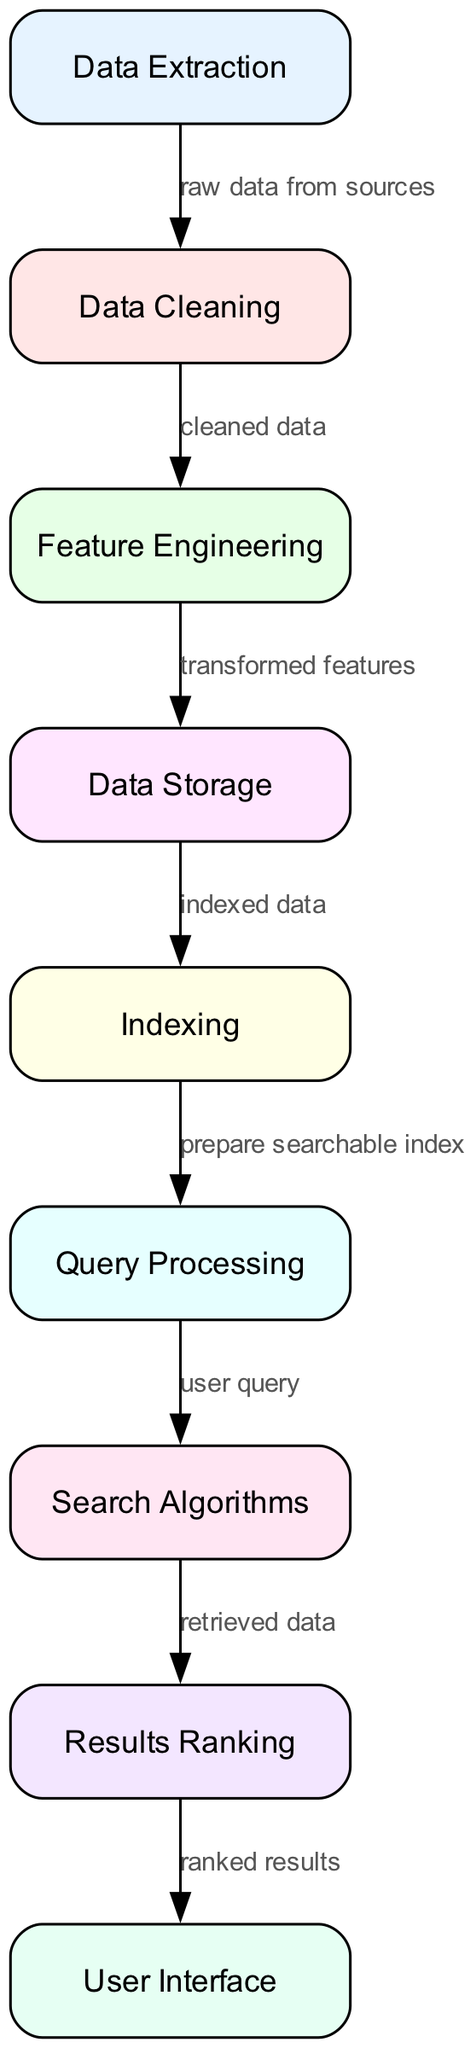What is the first stage in the data retrieval workflow? The diagram indicates that the first stage is labeled "Data Extraction," which is the starting point for processing raw data.
Answer: Data Extraction How many nodes are present in the diagram? By counting the listed nodes, there are a total of nine nodes represented in the diagram.
Answer: Nine Which node follows "Data Cleaning"? The diagram shows that "Feature Engineering" is the node that comes immediately after "Data Cleaning," indicating the next step in the process.
Answer: Feature Engineering What label is used for the edge between "Data Storage" and "Indexing"? The edge connecting "Data Storage" and "Indexing" is labeled "indexed data," signifying the type of data being processed between these two stages.
Answer: indexed data What process occurs after "Query Processing"? According to the diagram, the process that follows "Query Processing" is "Search Algorithms," which indicates the next stage in handling user queries.
Answer: Search Algorithms What is the role of the node labeled "Results Ranking"? The node labeled "Results Ranking" is responsible for sorting the retrieved data based on relevance or quality before presenting it to the user.
Answer: sorting How does data move from "Feature Engineering" to "Data Storage"? Based on the diagram, data transitions from "Feature Engineering" to "Data Storage" through the labeled edge "transformed features," which represents the output of the feature engineering stage.
Answer: transformed features What is the relationship between "Search Algorithms" and "Results Ranking"? The diagram illustrates that "Search Algorithms" retrieves data, which is then processed for relevance prioritization in "Results Ranking," representing a functional flow of data processing.
Answer: retrieved data What comes before "User Interface" in the workflow? "Results Ranking" is the node that directly precedes "User Interface" in the diagram, indicating the last step before the results are presented to the user.
Answer: Results Ranking 